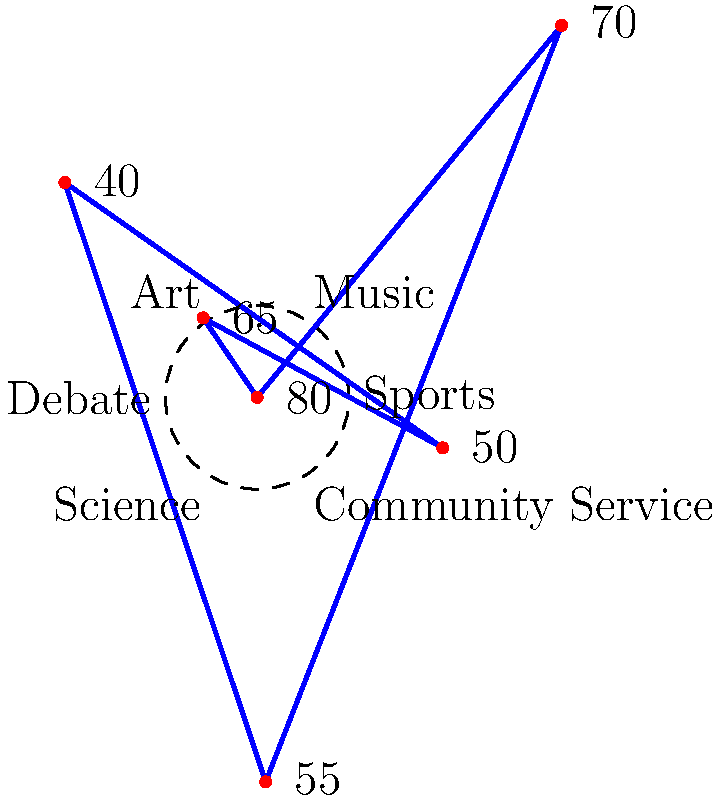As the class president, you've collected data on student participation rates in various extracurricular activities. The polar plot above shows the percentage of students participating in each activity. Which extracurricular activity has the highest participation rate, and what strategy would you propose to increase participation in the activity with the lowest rate? To answer this question, we need to analyze the polar plot:

1. Identify the activities and their participation rates:
   - Sports: 80%
   - Music: 65%
   - Art: 50%
   - Debate: 40%
   - Science: 55%
   - Community Service: 70%

2. Determine the highest participation rate:
   The highest rate is 80%, corresponding to Sports.

3. Identify the lowest participation rate:
   The lowest rate is 40%, corresponding to Debate.

4. Propose a strategy to increase participation in Debate:
   As class president, you could:
   a) Conduct a survey to understand why Debate has low participation
   b) Organize a Debate showcase or competition to generate interest
   c) Invite successful debaters or public speakers to inspire students
   d) Allocate more funds to the Debate club for resources and events
   e) Create a mentorship program pairing experienced debaters with newcomers
   f) Integrate debate skills into other subjects to demonstrate their value

The strategy should focus on raising awareness, demonstrating the benefits of debate skills, and making the activity more accessible and appealing to a wider range of students.
Answer: Sports (80%); Increase Debate (40%) participation through awareness, showcases, mentorship, and curriculum integration. 